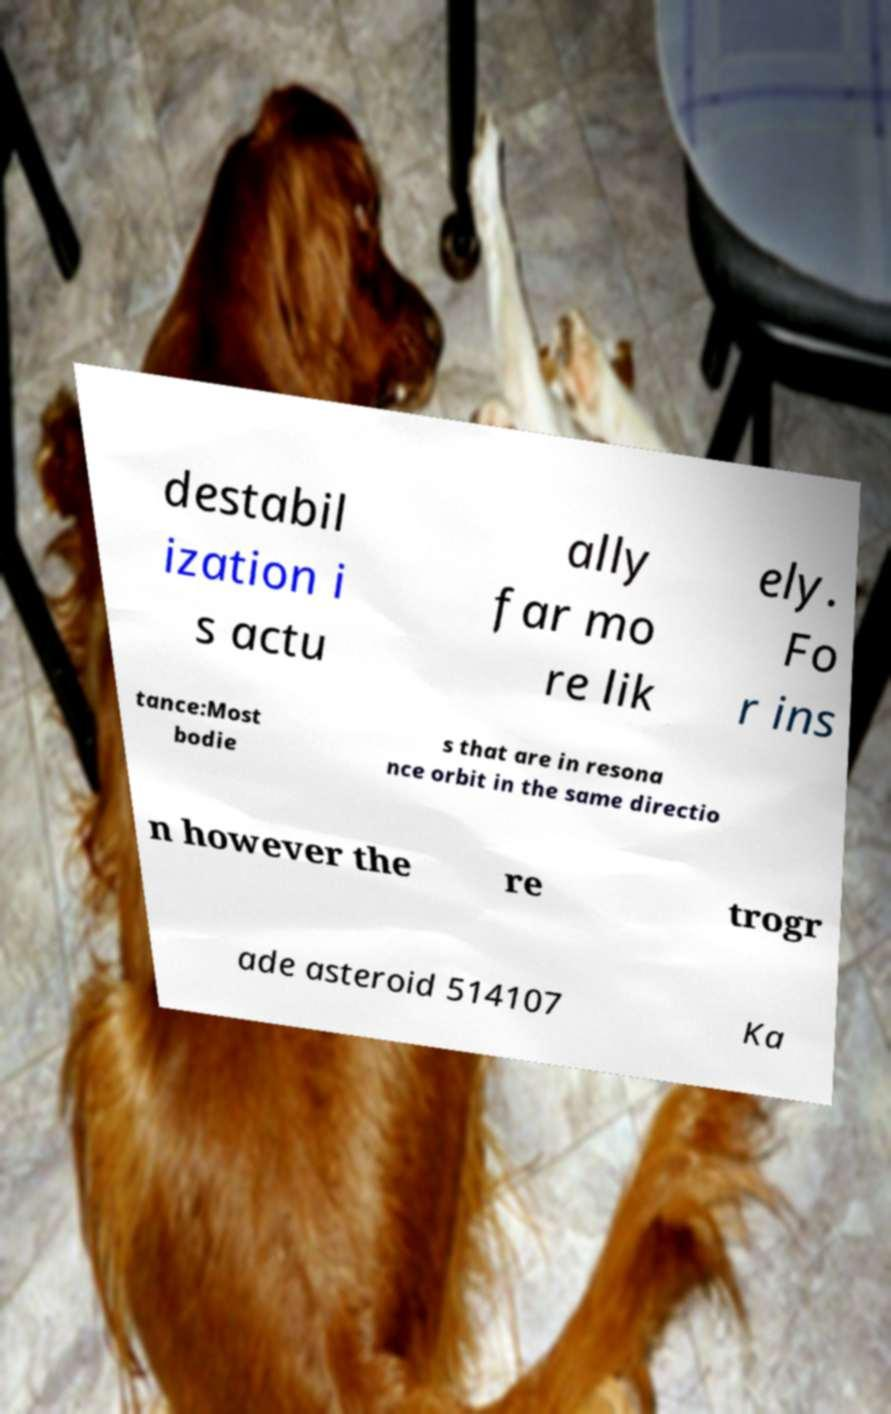There's text embedded in this image that I need extracted. Can you transcribe it verbatim? destabil ization i s actu ally far mo re lik ely. Fo r ins tance:Most bodie s that are in resona nce orbit in the same directio n however the re trogr ade asteroid 514107 Ka 